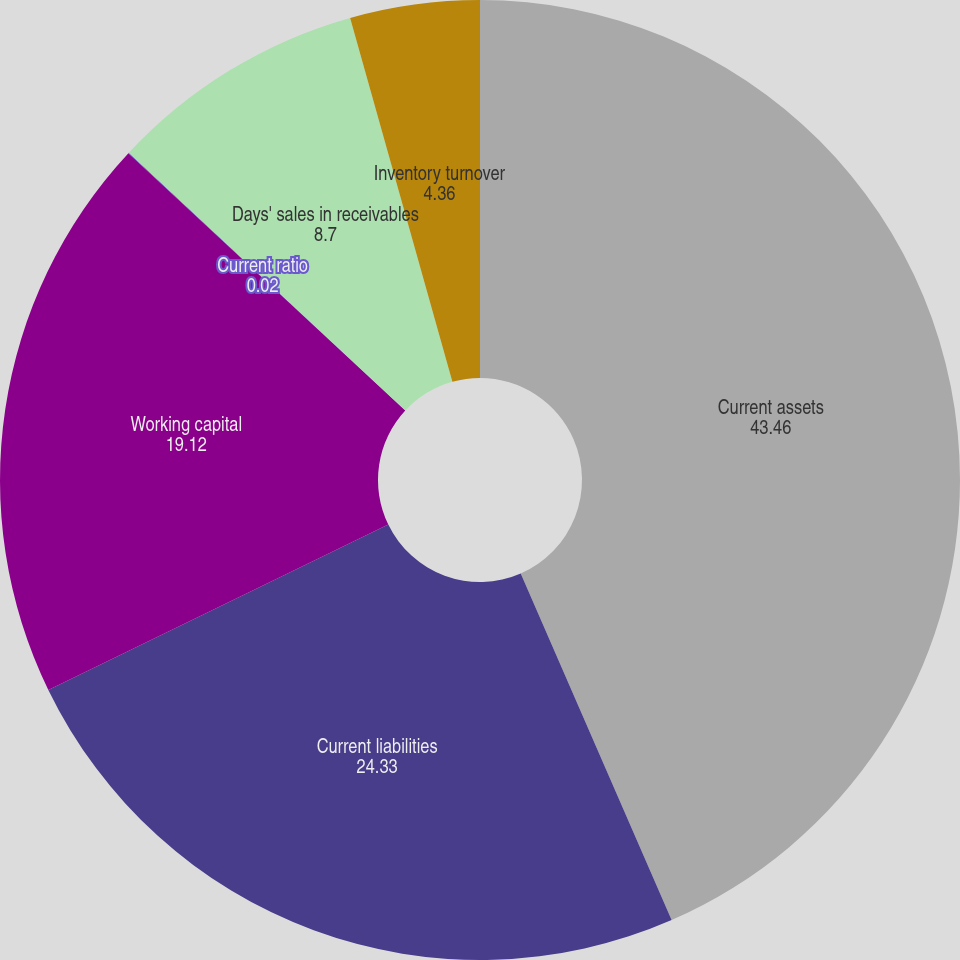<chart> <loc_0><loc_0><loc_500><loc_500><pie_chart><fcel>Current assets<fcel>Current liabilities<fcel>Working capital<fcel>Current ratio<fcel>Days' sales in receivables<fcel>Inventory turnover<nl><fcel>43.46%<fcel>24.33%<fcel>19.12%<fcel>0.02%<fcel>8.7%<fcel>4.36%<nl></chart> 